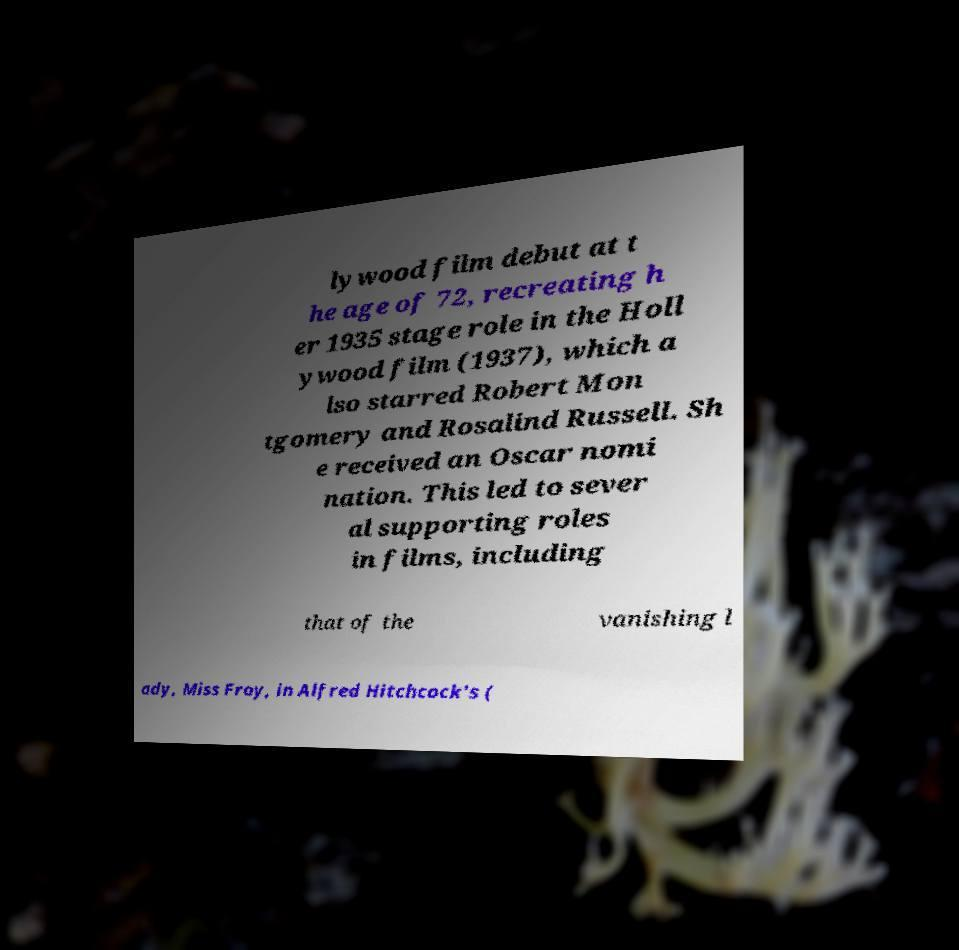I need the written content from this picture converted into text. Can you do that? lywood film debut at t he age of 72, recreating h er 1935 stage role in the Holl ywood film (1937), which a lso starred Robert Mon tgomery and Rosalind Russell. Sh e received an Oscar nomi nation. This led to sever al supporting roles in films, including that of the vanishing l ady, Miss Froy, in Alfred Hitchcock's ( 